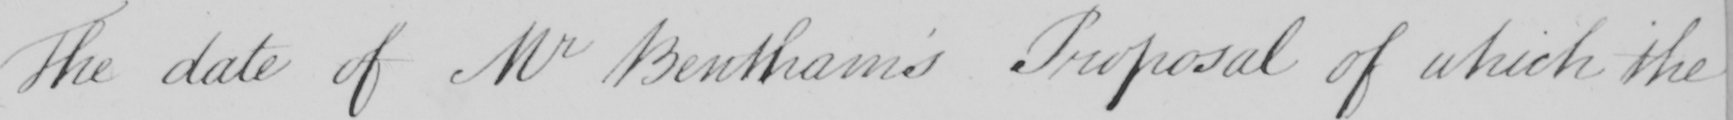Can you read and transcribe this handwriting? The date of Mr Bentham ' s Proposal of which the 